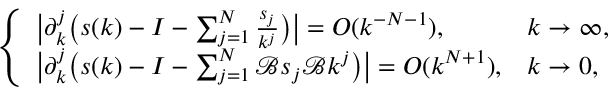<formula> <loc_0><loc_0><loc_500><loc_500>\begin{array} { r } { \left \{ \begin{array} { l l } { \left | \partial _ { k } ^ { j } \left ( s ( k ) - I - \sum _ { j = 1 } ^ { N } \frac { s _ { j } } { k ^ { j } } \right ) \right | = O ( k ^ { - N - 1 } ) , } & { k \to \infty , } \\ { \left | \partial _ { k } ^ { j } \left ( s ( k ) - I - \sum _ { j = 1 } ^ { N } \mathcal { B } s _ { j } \mathcal { B } k ^ { j } \right ) \right | = O ( k ^ { N + 1 } ) , } & { k \to 0 , } \end{array} } \end{array}</formula> 